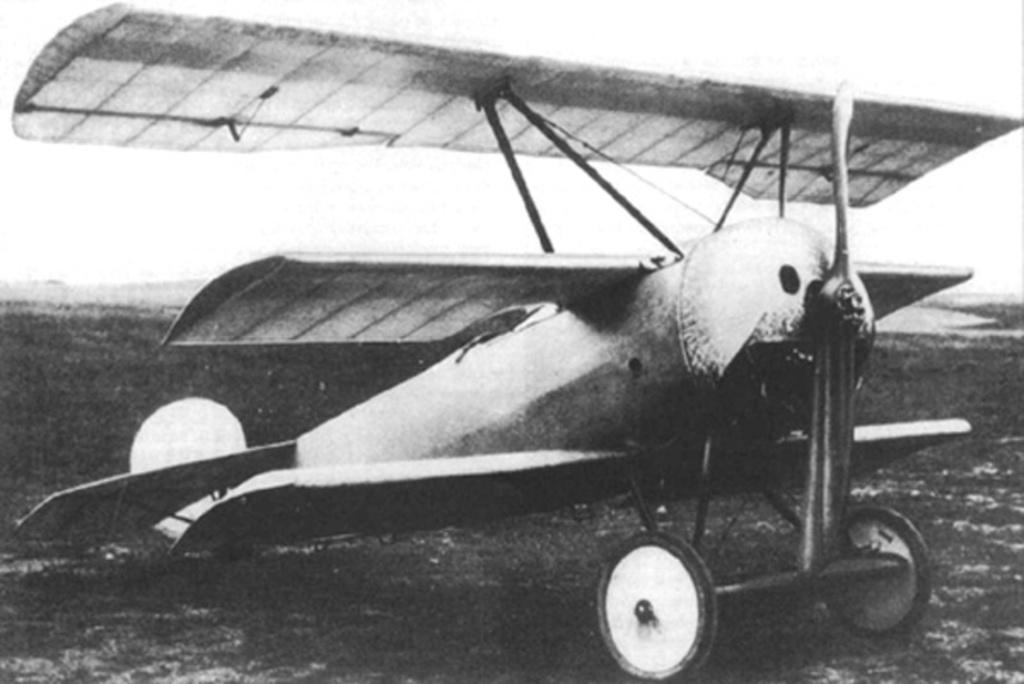What is the main subject of the image? The main subject of the image is an aircraft. Where is the aircraft located in the image? The aircraft is on the ground in the image. What can be seen in the background of the image? The sky is visible in the background of the image. What is the color scheme of the image? The image is black and white. What type of pancake is being served at the event in the image? There is no event or pancake present in the image; it features an aircraft on the ground with a black and white color scheme. 